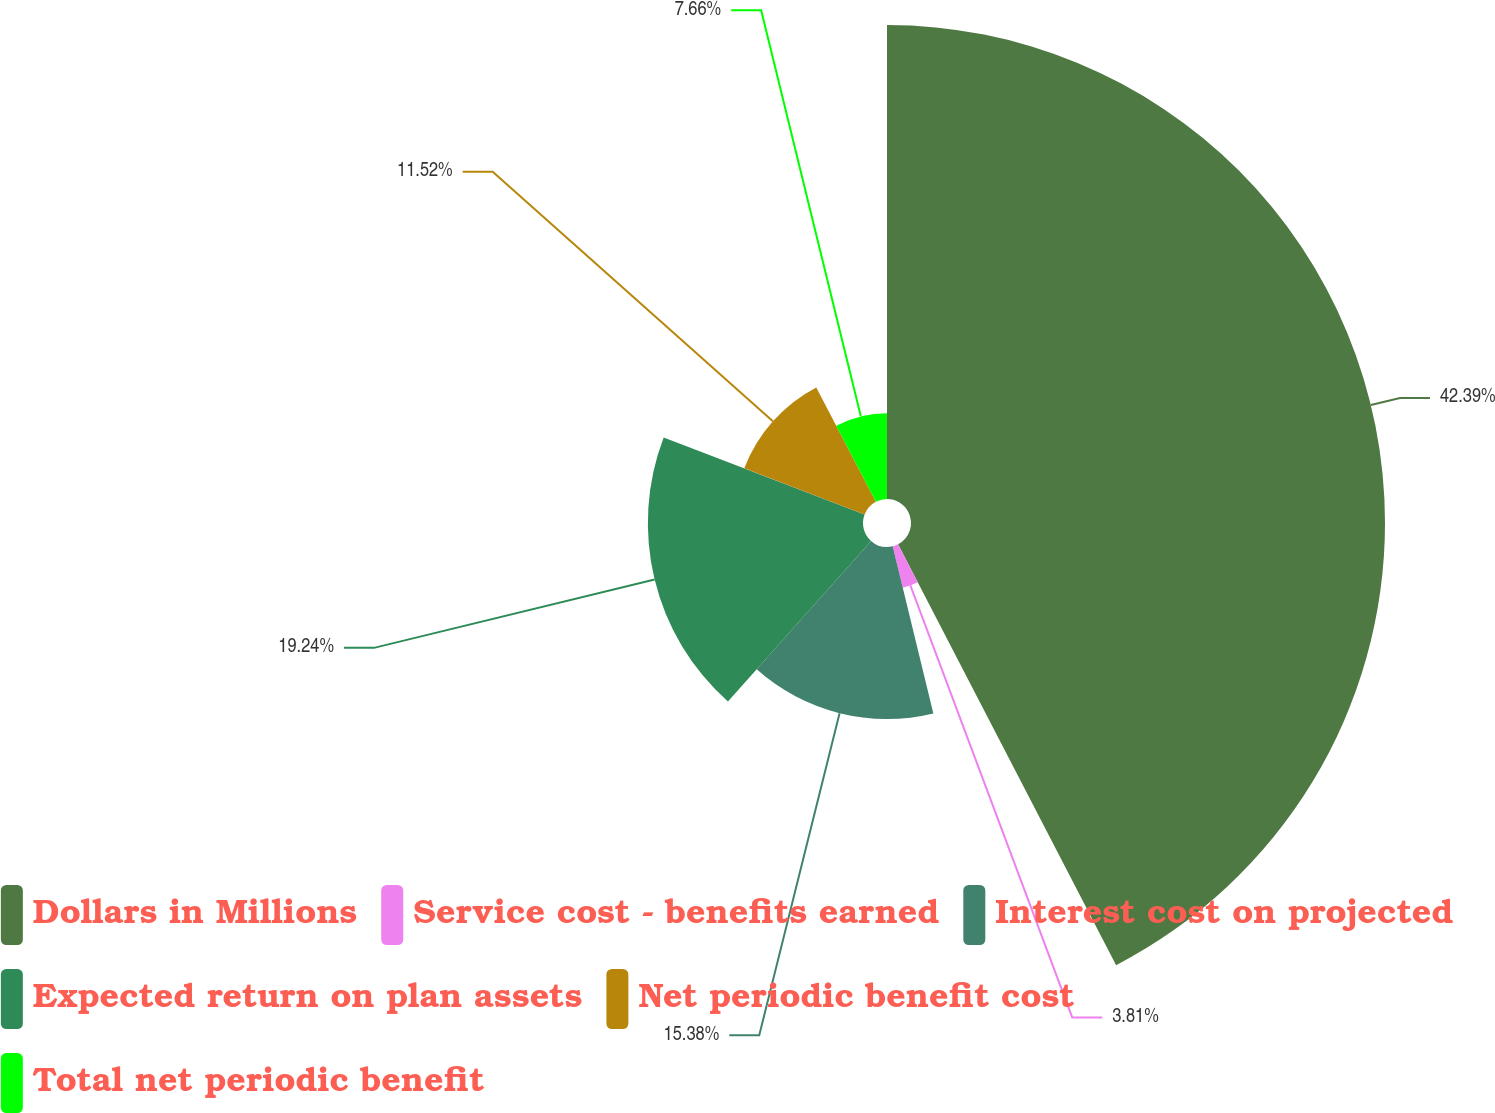Convert chart. <chart><loc_0><loc_0><loc_500><loc_500><pie_chart><fcel>Dollars in Millions<fcel>Service cost - benefits earned<fcel>Interest cost on projected<fcel>Expected return on plan assets<fcel>Net periodic benefit cost<fcel>Total net periodic benefit<nl><fcel>42.39%<fcel>3.81%<fcel>15.38%<fcel>19.24%<fcel>11.52%<fcel>7.66%<nl></chart> 